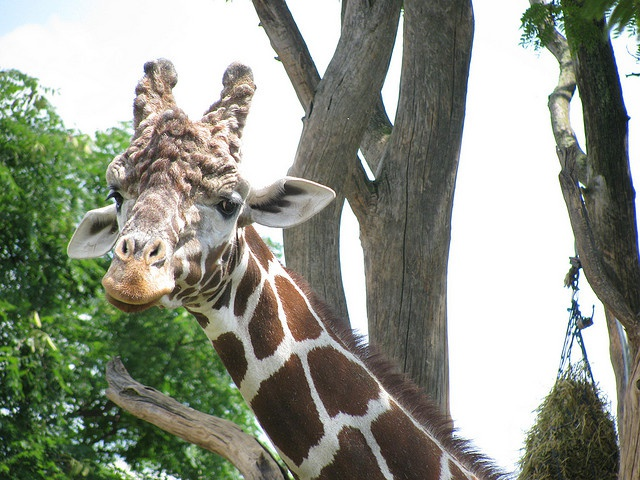Describe the objects in this image and their specific colors. I can see a giraffe in lightblue, darkgray, gray, black, and lightgray tones in this image. 